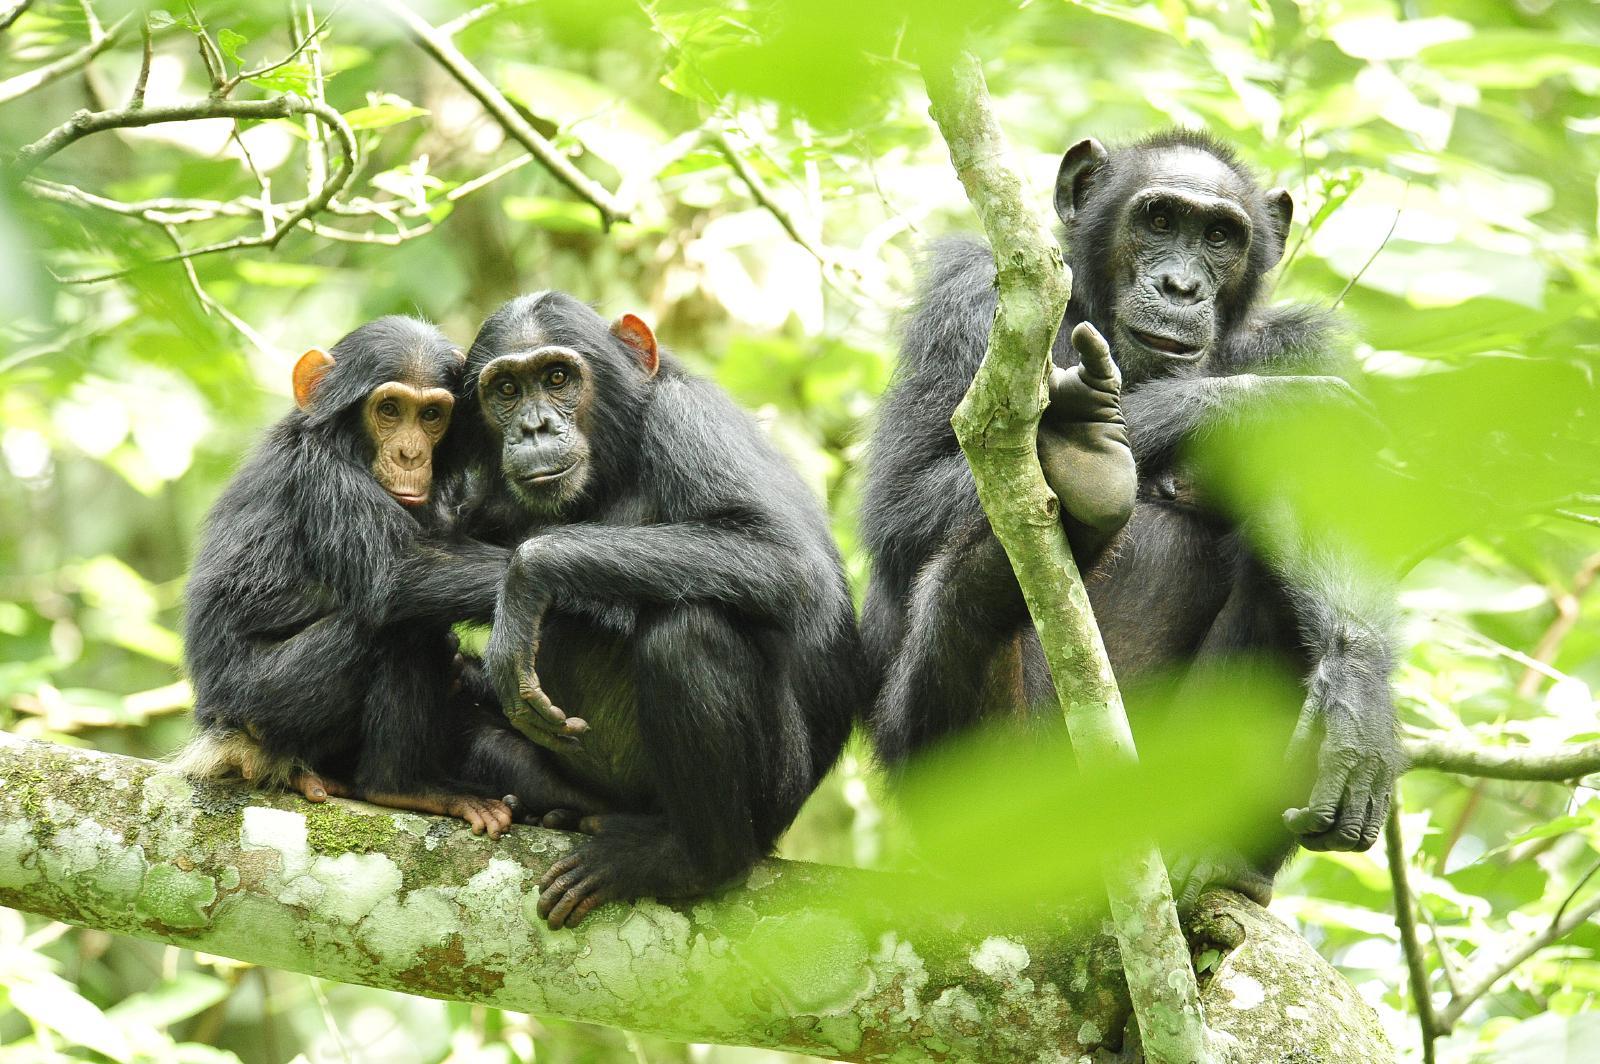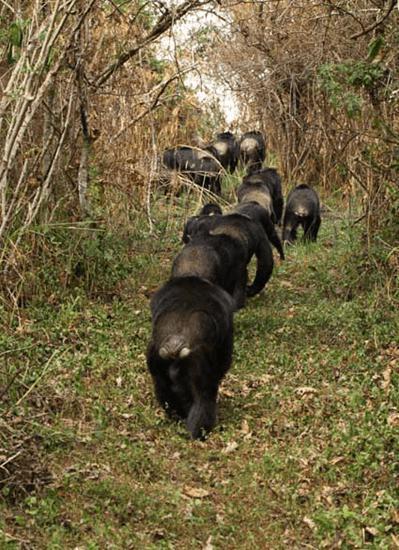The first image is the image on the left, the second image is the image on the right. For the images displayed, is the sentence "The image on the left contains three chimpanzees." factually correct? Answer yes or no. Yes. The first image is the image on the left, the second image is the image on the right. Assess this claim about the two images: "In one of the image there are 3 chimpanzees on a branch.". Correct or not? Answer yes or no. Yes. 